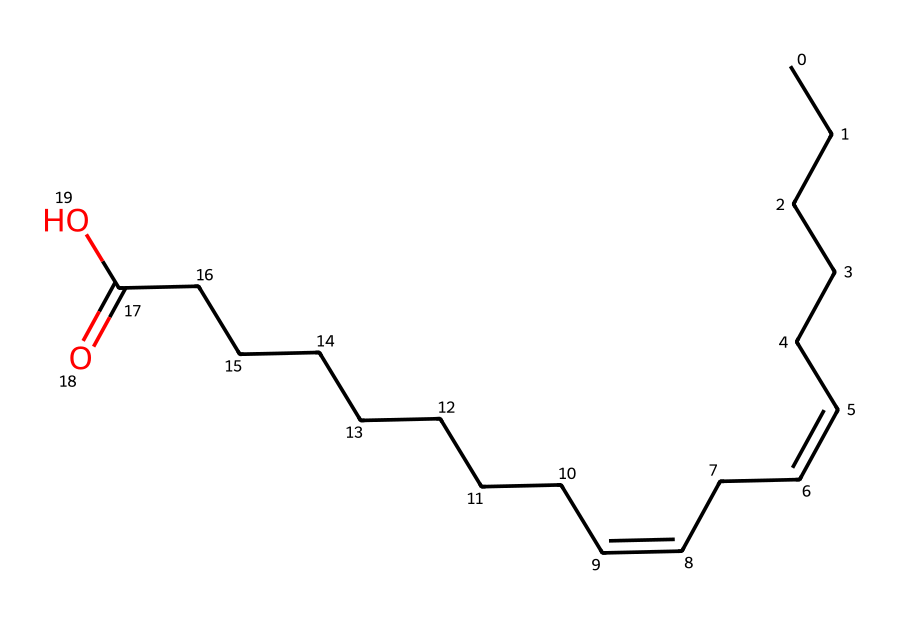What is the main functional group present in this sunflower oil structure? The structure shows a carboxylic acid group at the end of the carbon chain (indicated by the -COOH part). This is characteristic of fatty acids.
Answer: carboxylic acid How many double bonds are present in the molecular structure? The SMILES representation shows two instances of "/C=C\\" indicating there are two double bonds in the carbon chain.
Answer: two What is the total number of carbon atoms in the molecule? By parsing the structure or visualizing the carbon chain and accounting for the carboxylic acid, there are 18 carbon atoms in total.
Answer: eighteen Is this molecule saturated or unsaturated? The presence of double bonds in the structure indicates that it is unsaturated as saturated compounds would not have any carbon-carbon double bonds.
Answer: unsaturated What type of fatty acid is represented by this molecule? The structure corresponds to linoleic acid, which is a polyunsaturated fatty acid due to multiple double bonds in its chain.
Answer: polyunsaturated fatty acid 